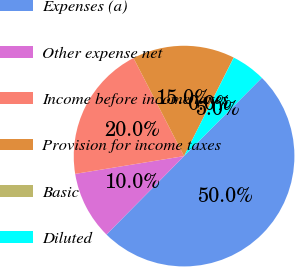Convert chart to OTSL. <chart><loc_0><loc_0><loc_500><loc_500><pie_chart><fcel>Expenses (a)<fcel>Other expense net<fcel>Income before income taxes<fcel>Provision for income taxes<fcel>Basic<fcel>Diluted<nl><fcel>49.97%<fcel>10.01%<fcel>20.0%<fcel>15.0%<fcel>0.02%<fcel>5.01%<nl></chart> 